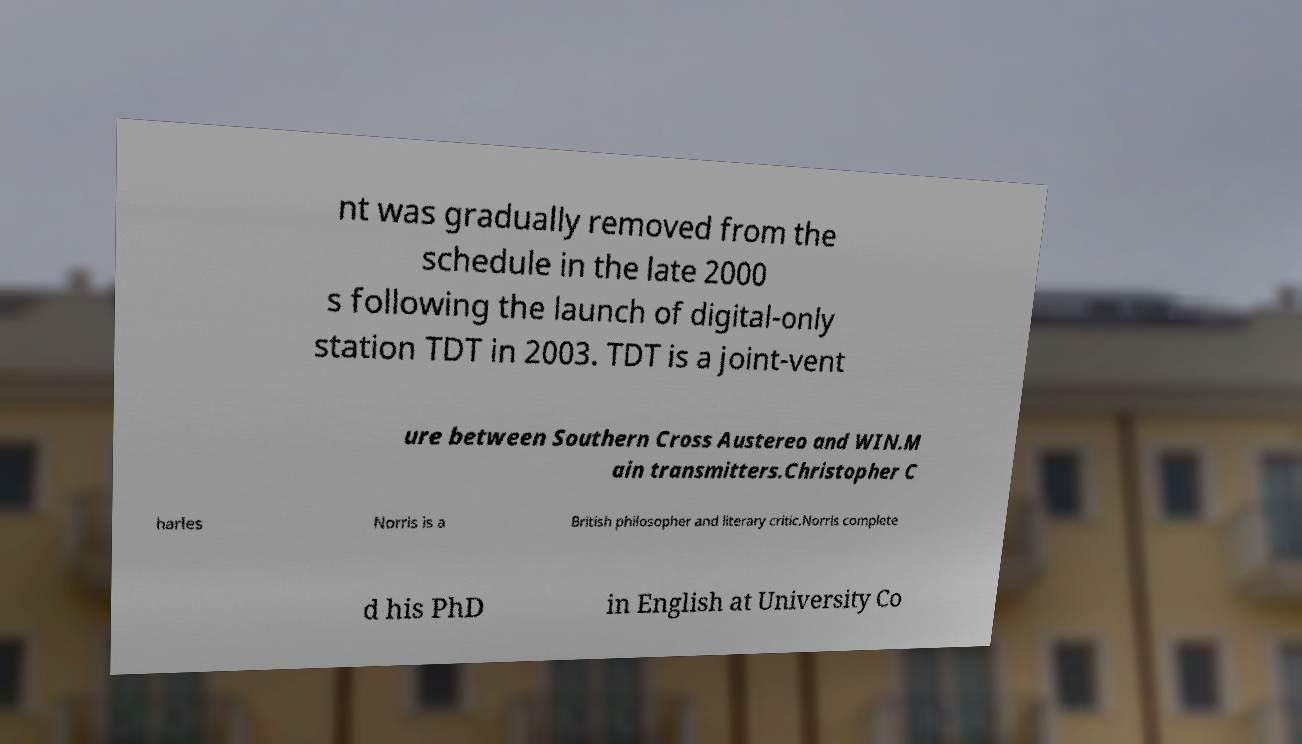Could you assist in decoding the text presented in this image and type it out clearly? nt was gradually removed from the schedule in the late 2000 s following the launch of digital-only station TDT in 2003. TDT is a joint-vent ure between Southern Cross Austereo and WIN.M ain transmitters.Christopher C harles Norris is a British philosopher and literary critic.Norris complete d his PhD in English at University Co 